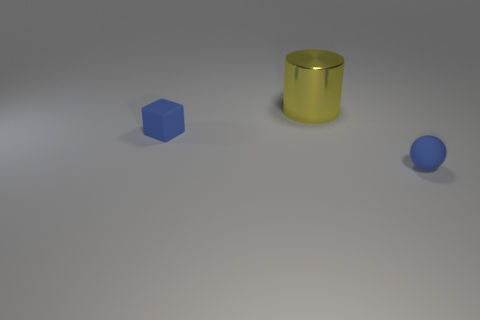Add 3 purple metal spheres. How many objects exist? 6 Subtract all balls. How many objects are left? 2 Add 1 blue balls. How many blue balls are left? 2 Add 3 tiny things. How many tiny things exist? 5 Subtract 0 brown balls. How many objects are left? 3 Subtract all large yellow objects. Subtract all large red rubber cylinders. How many objects are left? 2 